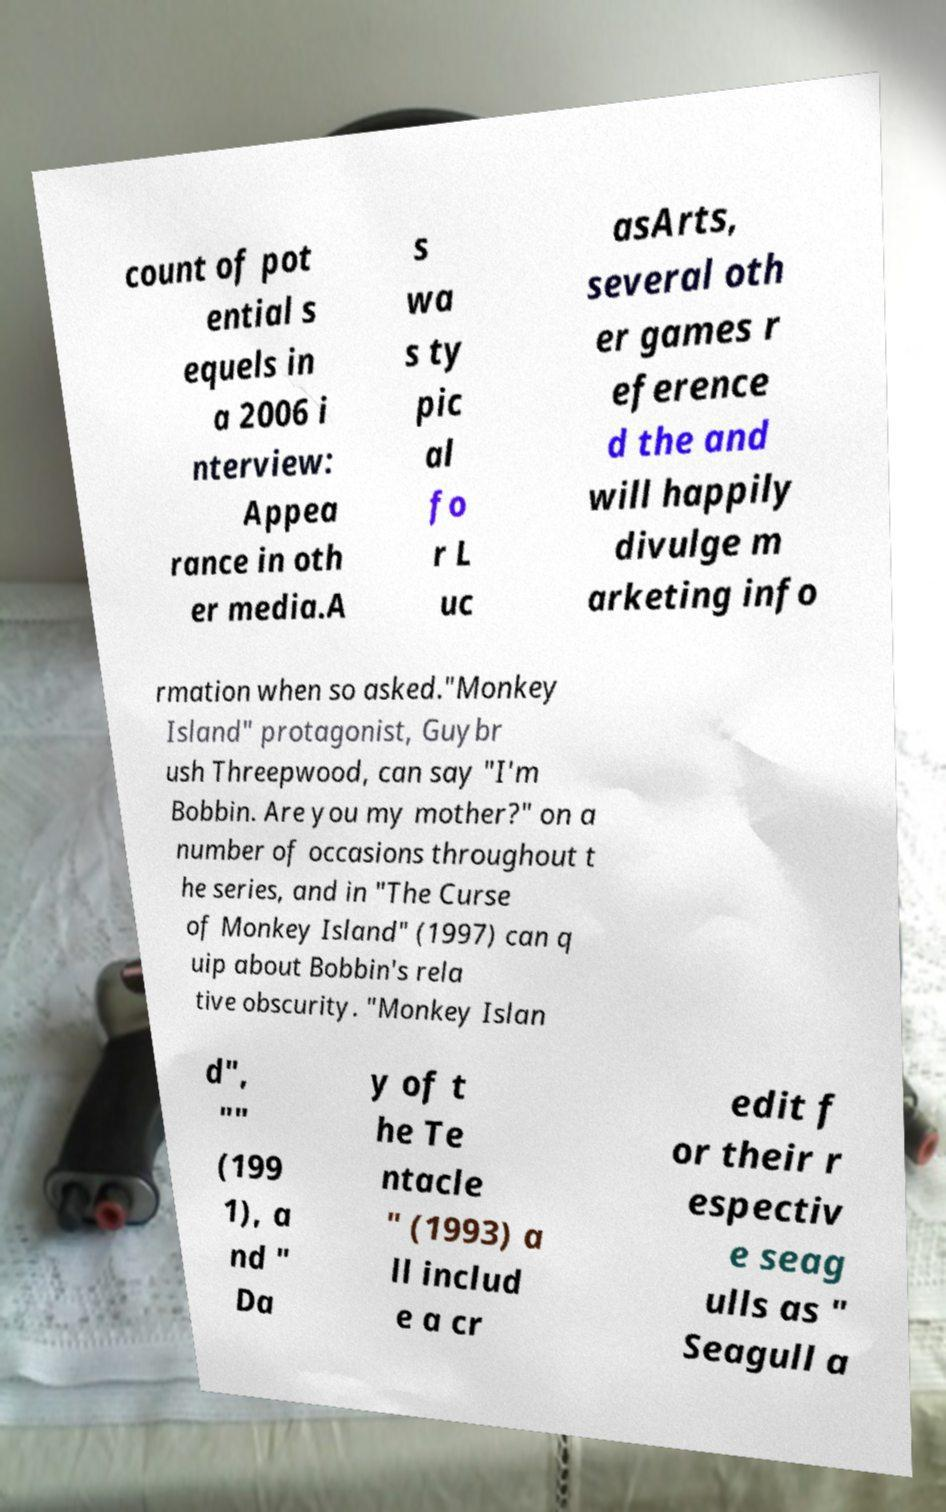Could you extract and type out the text from this image? count of pot ential s equels in a 2006 i nterview: Appea rance in oth er media.A s wa s ty pic al fo r L uc asArts, several oth er games r eference d the and will happily divulge m arketing info rmation when so asked."Monkey Island" protagonist, Guybr ush Threepwood, can say "I'm Bobbin. Are you my mother?" on a number of occasions throughout t he series, and in "The Curse of Monkey Island" (1997) can q uip about Bobbin's rela tive obscurity. "Monkey Islan d", "" (199 1), a nd " Da y of t he Te ntacle " (1993) a ll includ e a cr edit f or their r espectiv e seag ulls as " Seagull a 